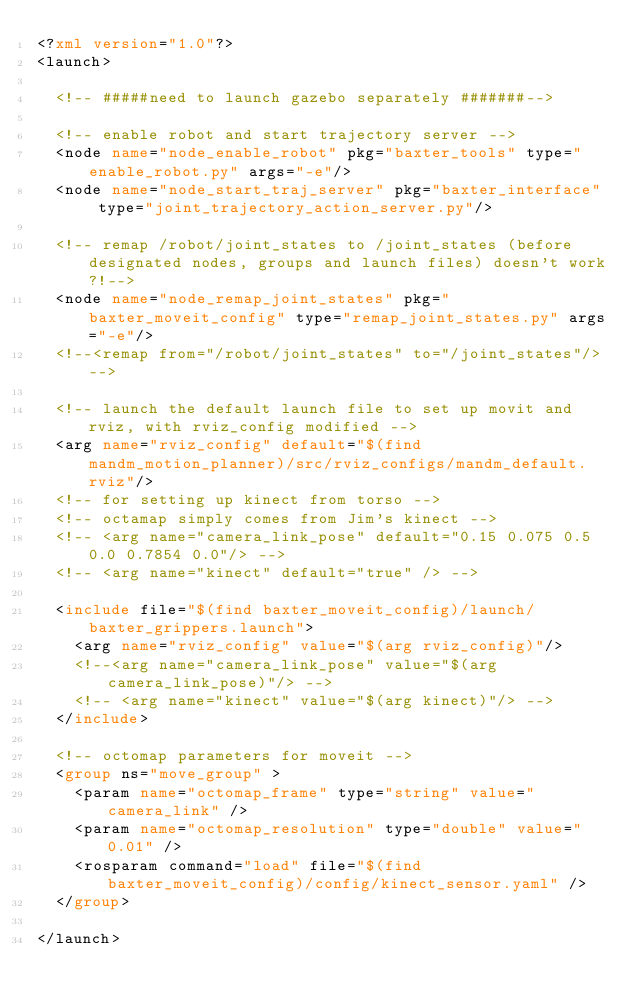<code> <loc_0><loc_0><loc_500><loc_500><_XML_><?xml version="1.0"?>
<launch>

  <!-- #####need to launch gazebo separately #######-->

  <!-- enable robot and start trajectory server -->
  <node name="node_enable_robot" pkg="baxter_tools" type="enable_robot.py" args="-e"/>
  <node name="node_start_traj_server" pkg="baxter_interface" type="joint_trajectory_action_server.py"/>

  <!-- remap /robot/joint_states to /joint_states (before designated nodes, groups and launch files) doesn't work?!-->
  <node name="node_remap_joint_states" pkg="baxter_moveit_config" type="remap_joint_states.py" args="-e"/>
  <!--<remap from="/robot/joint_states" to="/joint_states"/>-->

  <!-- launch the default launch file to set up movit and rviz, with rviz_config modified -->
  <arg name="rviz_config" default="$(find mandm_motion_planner)/src/rviz_configs/mandm_default.rviz"/>
  <!-- for setting up kinect from torso -->
  <!-- octamap simply comes from Jim's kinect -->
  <!-- <arg name="camera_link_pose" default="0.15 0.075 0.5 0.0 0.7854 0.0"/> -->
  <!-- <arg name="kinect" default="true" /> -->

  <include file="$(find baxter_moveit_config)/launch/baxter_grippers.launch">
    <arg name="rviz_config" value="$(arg rviz_config)"/>
    <!--<arg name="camera_link_pose" value="$(arg camera_link_pose)"/> -->
    <!-- <arg name="kinect" value="$(arg kinect)"/> -->
  </include>

  <!-- octomap parameters for moveit -->
  <group ns="move_group" >
    <param name="octomap_frame" type="string" value="camera_link" />
    <param name="octomap_resolution" type="double" value="0.01" />
    <rosparam command="load" file="$(find baxter_moveit_config)/config/kinect_sensor.yaml" />
  </group>

</launch>
</code> 